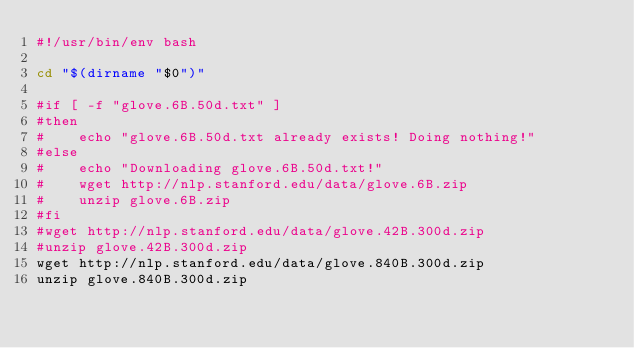Convert code to text. <code><loc_0><loc_0><loc_500><loc_500><_Bash_>#!/usr/bin/env bash

cd "$(dirname "$0")"

#if [ -f "glove.6B.50d.txt" ]
#then
#    echo "glove.6B.50d.txt already exists! Doing nothing!"
#else
#    echo "Downloading glove.6B.50d.txt!"
#    wget http://nlp.stanford.edu/data/glove.6B.zip
#    unzip glove.6B.zip
#fi
#wget http://nlp.stanford.edu/data/glove.42B.300d.zip
#unzip glove.42B.300d.zip
wget http://nlp.stanford.edu/data/glove.840B.300d.zip
unzip glove.840B.300d.zip
</code> 